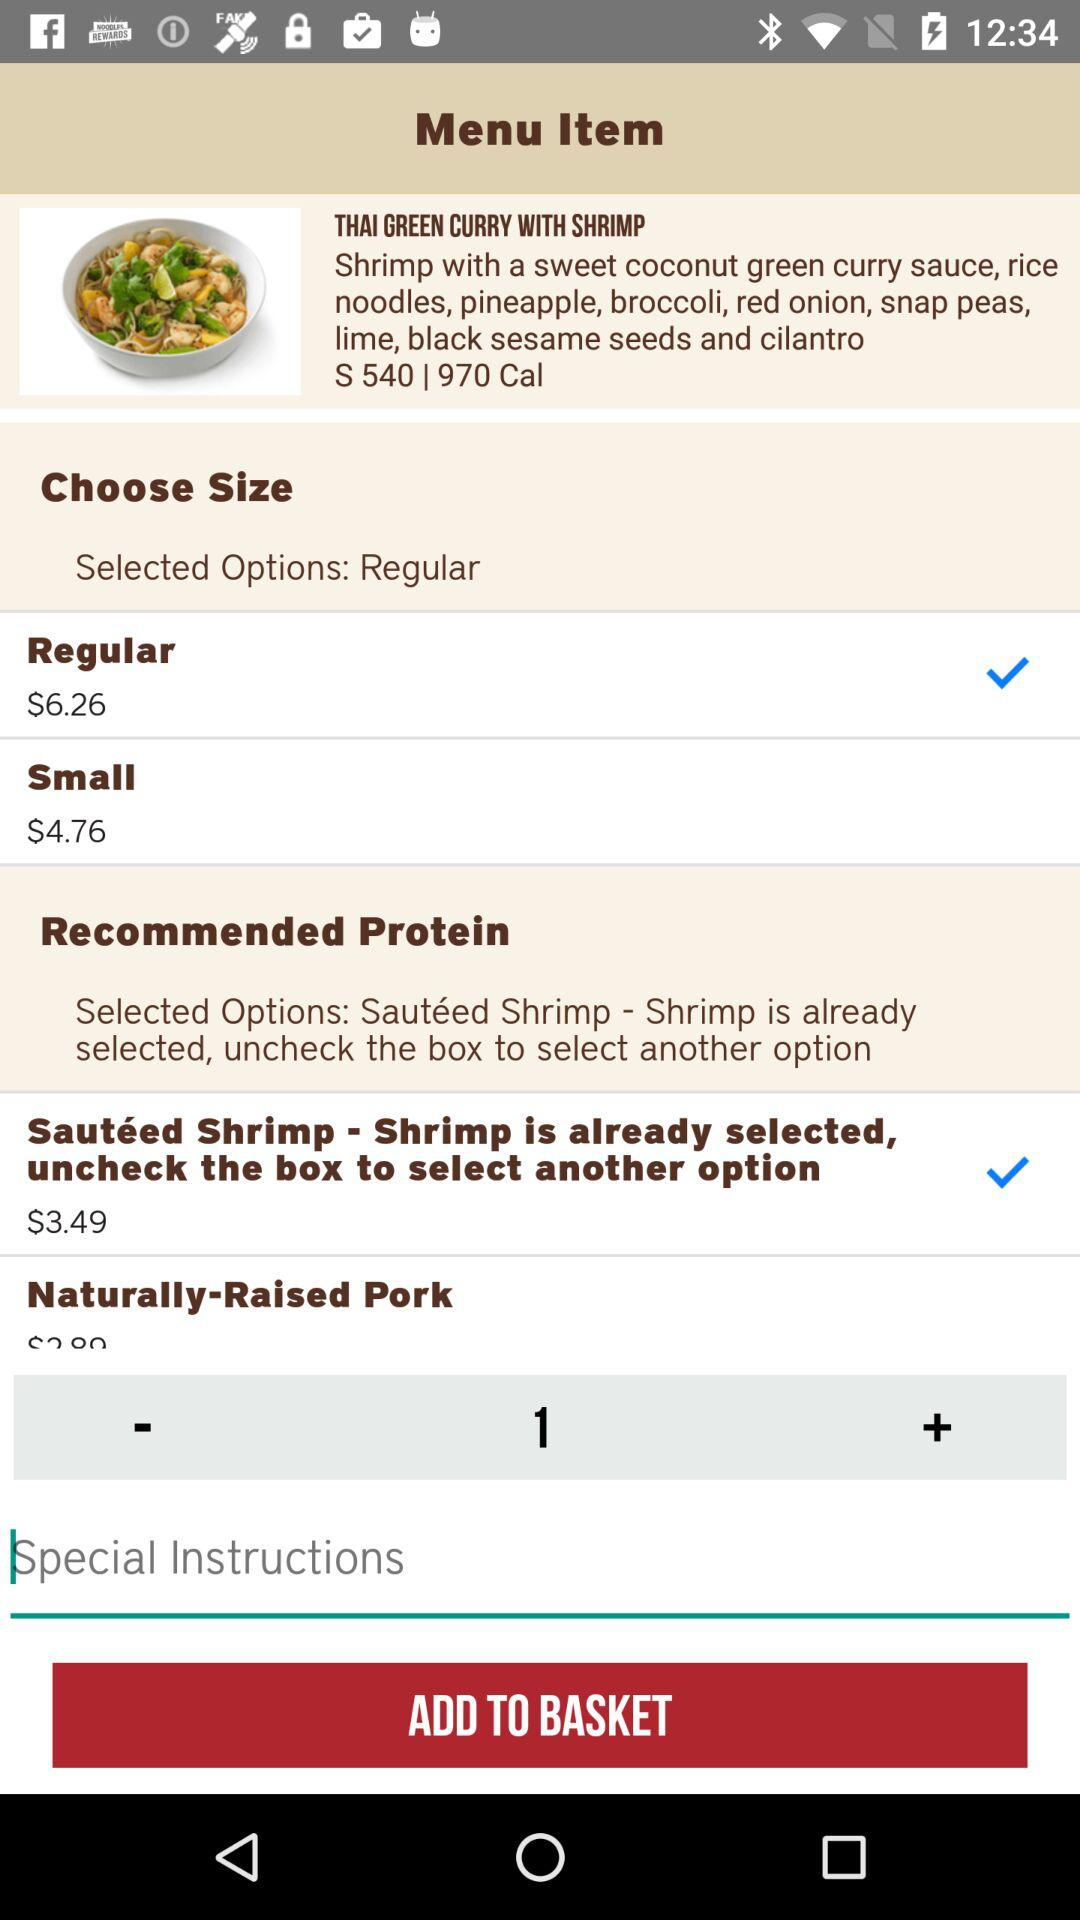What is the size of the dish that has a price of $6.26? The size of the dish that has a price of $6.26 is regular. 